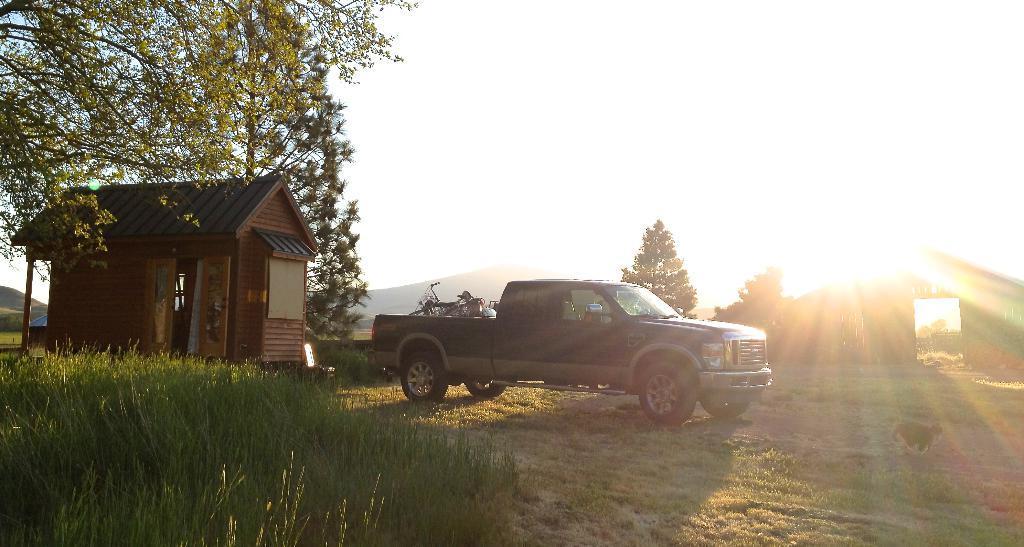Could you give a brief overview of what you see in this image? In this picture there is a truck, parked near to the hut. On the left we can see the door and window. In the bottom left we can see the grass. In the bottom right there is a dog standing on the ground. On the right there is a wooden shed. In the background we can see the trees and mountains. At the top there is a sky. Here it's a sun. 